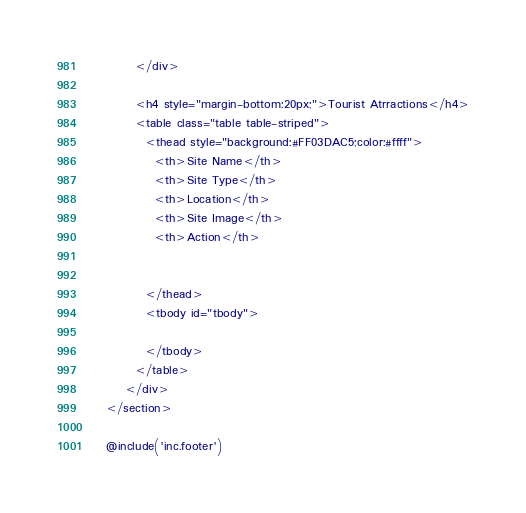Convert code to text. <code><loc_0><loc_0><loc_500><loc_500><_PHP_>          </div>

          <h4 style="margin-bottom:20px;">Tourist Atrractions</h4>
          <table class="table table-striped">
            <thead style="background:#FF03DAC5;color:#ffff">
              <th>Site Name</th>
              <th>Site Type</th>
              <th>Location</th>
              <th>Site Image</th>
              <th>Action</th>


            </thead>
            <tbody id="tbody">

            </tbody>
          </table>
        </div>
    </section>

    @include('inc.footer')
</code> 